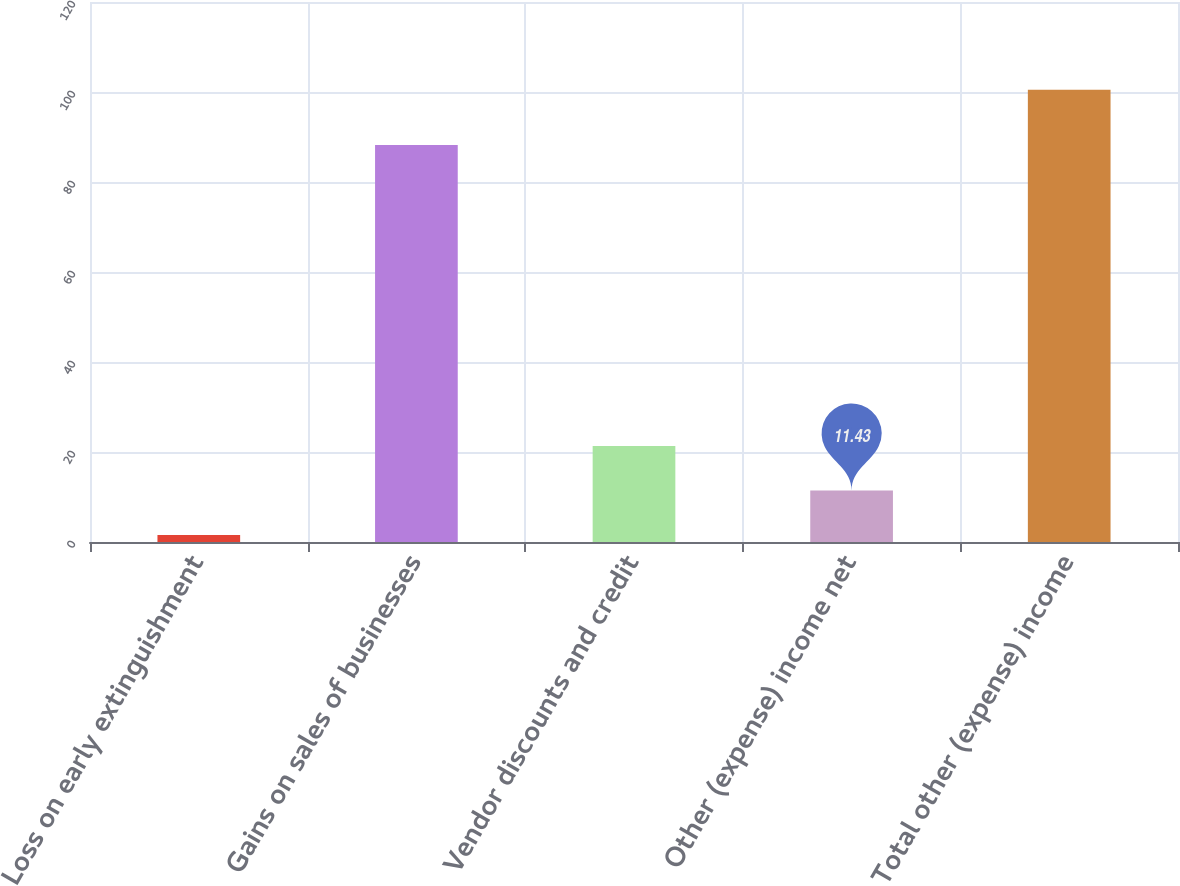Convert chart to OTSL. <chart><loc_0><loc_0><loc_500><loc_500><bar_chart><fcel>Loss on early extinguishment<fcel>Gains on sales of businesses<fcel>Vendor discounts and credit<fcel>Other (expense) income net<fcel>Total other (expense) income<nl><fcel>1.53<fcel>88.2<fcel>21.33<fcel>11.43<fcel>100.5<nl></chart> 